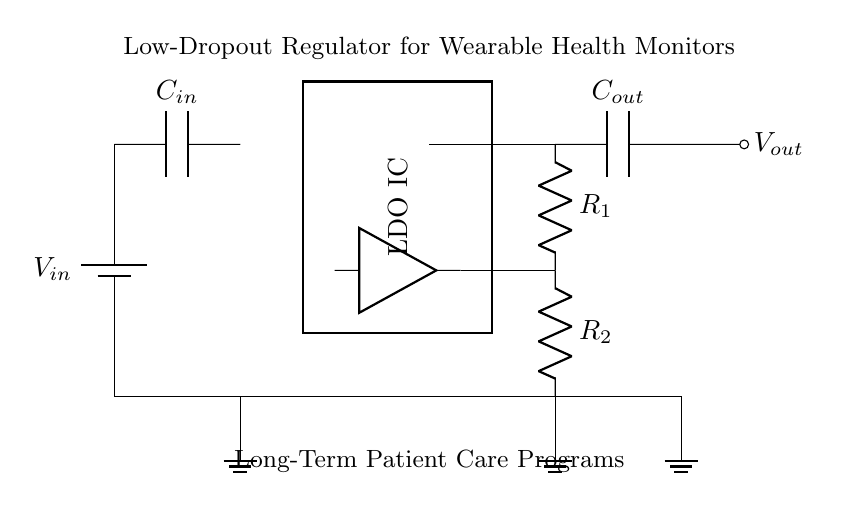What is the input voltage of the circuit? The input voltage is labeled as V_in. This indicates that it is the voltage supplied to the circuit.
Answer: V_in What type of transistor is used in this circuit? The circuit specifically shows a PNP transistor, which is indicated by the symbol for the pass transistor in the diagram.
Answer: PNP What does the error amplifier do? The error amplifier compares the output voltage with a reference voltage to regulate the output voltage, ensuring it remains stable.
Answer: Regulates output voltage How many resistors are in the feedback network? There are two resistors, R_1 and R_2, connected in the feedback loop as shown in the diagram.
Answer: Two What is the purpose of the output capacitor? The output capacitor smooths the output voltage by reducing ripple, thus stabilizing the voltage supplied to the wearable device.
Answer: Smooths output voltage What is the overall function of this low-dropout regulator? The overall function is to provide a stable output voltage from a varying input voltage while maintaining low voltage dropout, suitable for powering wearable health devices.
Answer: Stabilizes output voltage What are the two voltage levels that this circuit is concerned with? The circuit is primarily concerned with V_in as the input voltage and V_out as the output voltage supplied to the load.
Answer: V_in and V_out 